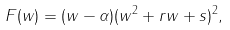Convert formula to latex. <formula><loc_0><loc_0><loc_500><loc_500>F ( w ) = ( w - \alpha ) ( w ^ { 2 } + r w + s ) ^ { 2 } ,</formula> 